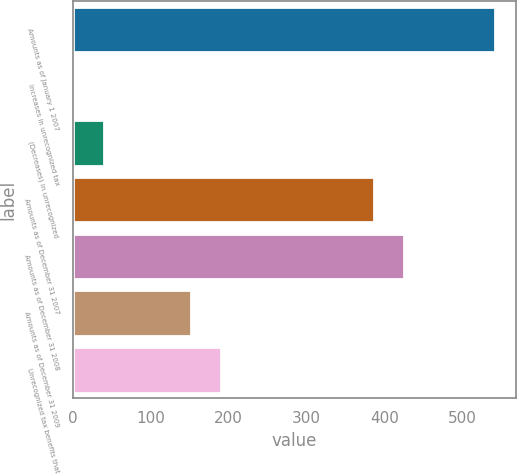<chart> <loc_0><loc_0><loc_500><loc_500><bar_chart><fcel>Amounts as of January 1 2007<fcel>Increases in unrecognized tax<fcel>(Decreases) in unrecognized<fcel>Amounts as of December 31 2007<fcel>Amounts as of December 31 2008<fcel>Amounts as of December 31 2009<fcel>Unrecognized tax benefits that<nl><fcel>542.2<fcel>1<fcel>39.8<fcel>387<fcel>425.8<fcel>152<fcel>190.8<nl></chart> 